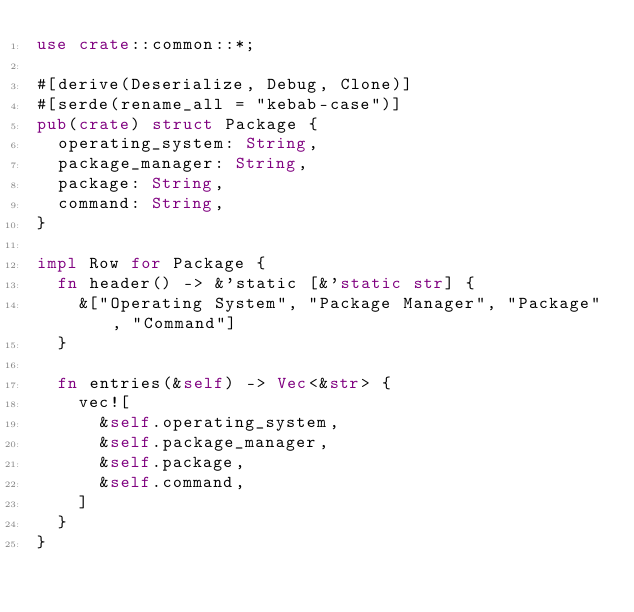Convert code to text. <code><loc_0><loc_0><loc_500><loc_500><_Rust_>use crate::common::*;

#[derive(Deserialize, Debug, Clone)]
#[serde(rename_all = "kebab-case")]
pub(crate) struct Package {
  operating_system: String,
  package_manager: String,
  package: String,
  command: String,
}

impl Row for Package {
  fn header() -> &'static [&'static str] {
    &["Operating System", "Package Manager", "Package", "Command"]
  }

  fn entries(&self) -> Vec<&str> {
    vec![
      &self.operating_system,
      &self.package_manager,
      &self.package,
      &self.command,
    ]
  }
}
</code> 